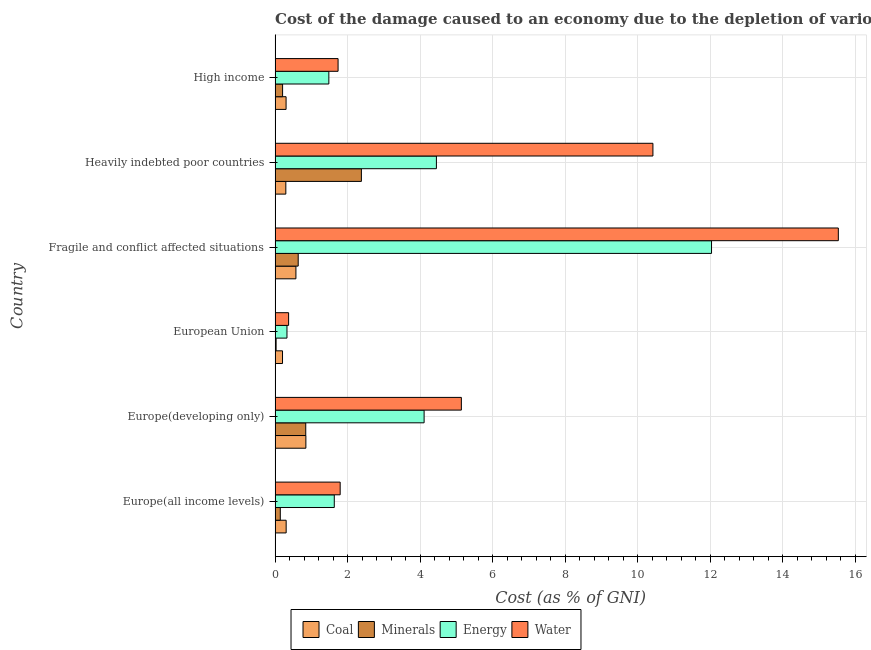How many different coloured bars are there?
Provide a succinct answer. 4. How many groups of bars are there?
Your response must be concise. 6. How many bars are there on the 6th tick from the top?
Keep it short and to the point. 4. How many bars are there on the 6th tick from the bottom?
Provide a succinct answer. 4. What is the label of the 6th group of bars from the top?
Offer a very short reply. Europe(all income levels). What is the cost of damage due to depletion of energy in Heavily indebted poor countries?
Your response must be concise. 4.45. Across all countries, what is the maximum cost of damage due to depletion of coal?
Your response must be concise. 0.85. Across all countries, what is the minimum cost of damage due to depletion of minerals?
Your answer should be very brief. 0.03. In which country was the cost of damage due to depletion of minerals maximum?
Your answer should be compact. Heavily indebted poor countries. What is the total cost of damage due to depletion of water in the graph?
Provide a short and direct response. 34.99. What is the difference between the cost of damage due to depletion of water in Europe(developing only) and that in Heavily indebted poor countries?
Provide a short and direct response. -5.28. What is the difference between the cost of damage due to depletion of water in Heavily indebted poor countries and the cost of damage due to depletion of energy in European Union?
Offer a terse response. 10.09. What is the average cost of damage due to depletion of coal per country?
Your response must be concise. 0.42. What is the difference between the cost of damage due to depletion of energy and cost of damage due to depletion of coal in High income?
Keep it short and to the point. 1.18. What is the ratio of the cost of damage due to depletion of energy in Europe(all income levels) to that in High income?
Offer a very short reply. 1.1. What is the difference between the highest and the second highest cost of damage due to depletion of minerals?
Offer a very short reply. 1.53. What is the difference between the highest and the lowest cost of damage due to depletion of energy?
Provide a succinct answer. 11.7. What does the 3rd bar from the top in Heavily indebted poor countries represents?
Offer a terse response. Minerals. What does the 1st bar from the bottom in High income represents?
Your response must be concise. Coal. Are all the bars in the graph horizontal?
Keep it short and to the point. Yes. Are the values on the major ticks of X-axis written in scientific E-notation?
Provide a succinct answer. No. Does the graph contain any zero values?
Provide a short and direct response. No. Does the graph contain grids?
Offer a terse response. Yes. Where does the legend appear in the graph?
Make the answer very short. Bottom center. How are the legend labels stacked?
Offer a very short reply. Horizontal. What is the title of the graph?
Give a very brief answer. Cost of the damage caused to an economy due to the depletion of various resources in 2010 . Does "Self-employed" appear as one of the legend labels in the graph?
Offer a very short reply. No. What is the label or title of the X-axis?
Your response must be concise. Cost (as % of GNI). What is the label or title of the Y-axis?
Ensure brevity in your answer.  Country. What is the Cost (as % of GNI) of Coal in Europe(all income levels)?
Make the answer very short. 0.31. What is the Cost (as % of GNI) of Minerals in Europe(all income levels)?
Your answer should be very brief. 0.14. What is the Cost (as % of GNI) of Energy in Europe(all income levels)?
Give a very brief answer. 1.63. What is the Cost (as % of GNI) in Water in Europe(all income levels)?
Give a very brief answer. 1.79. What is the Cost (as % of GNI) of Coal in Europe(developing only)?
Your answer should be compact. 0.85. What is the Cost (as % of GNI) in Minerals in Europe(developing only)?
Ensure brevity in your answer.  0.85. What is the Cost (as % of GNI) in Energy in Europe(developing only)?
Offer a very short reply. 4.11. What is the Cost (as % of GNI) of Water in Europe(developing only)?
Offer a very short reply. 5.14. What is the Cost (as % of GNI) of Coal in European Union?
Your answer should be very brief. 0.21. What is the Cost (as % of GNI) of Minerals in European Union?
Your response must be concise. 0.03. What is the Cost (as % of GNI) in Energy in European Union?
Offer a very short reply. 0.33. What is the Cost (as % of GNI) of Water in European Union?
Offer a terse response. 0.37. What is the Cost (as % of GNI) of Coal in Fragile and conflict affected situations?
Keep it short and to the point. 0.57. What is the Cost (as % of GNI) of Minerals in Fragile and conflict affected situations?
Offer a terse response. 0.64. What is the Cost (as % of GNI) of Energy in Fragile and conflict affected situations?
Provide a succinct answer. 12.03. What is the Cost (as % of GNI) in Water in Fragile and conflict affected situations?
Your answer should be compact. 15.53. What is the Cost (as % of GNI) in Coal in Heavily indebted poor countries?
Your response must be concise. 0.3. What is the Cost (as % of GNI) in Minerals in Heavily indebted poor countries?
Make the answer very short. 2.38. What is the Cost (as % of GNI) of Energy in Heavily indebted poor countries?
Provide a short and direct response. 4.45. What is the Cost (as % of GNI) of Water in Heavily indebted poor countries?
Your response must be concise. 10.42. What is the Cost (as % of GNI) in Coal in High income?
Offer a terse response. 0.3. What is the Cost (as % of GNI) in Minerals in High income?
Give a very brief answer. 0.21. What is the Cost (as % of GNI) in Energy in High income?
Ensure brevity in your answer.  1.48. What is the Cost (as % of GNI) in Water in High income?
Keep it short and to the point. 1.74. Across all countries, what is the maximum Cost (as % of GNI) of Coal?
Give a very brief answer. 0.85. Across all countries, what is the maximum Cost (as % of GNI) in Minerals?
Offer a terse response. 2.38. Across all countries, what is the maximum Cost (as % of GNI) in Energy?
Your answer should be very brief. 12.03. Across all countries, what is the maximum Cost (as % of GNI) in Water?
Keep it short and to the point. 15.53. Across all countries, what is the minimum Cost (as % of GNI) in Coal?
Offer a terse response. 0.21. Across all countries, what is the minimum Cost (as % of GNI) of Minerals?
Offer a very short reply. 0.03. Across all countries, what is the minimum Cost (as % of GNI) of Energy?
Your response must be concise. 0.33. Across all countries, what is the minimum Cost (as % of GNI) in Water?
Your answer should be very brief. 0.37. What is the total Cost (as % of GNI) of Coal in the graph?
Provide a succinct answer. 2.53. What is the total Cost (as % of GNI) in Minerals in the graph?
Offer a terse response. 4.24. What is the total Cost (as % of GNI) of Energy in the graph?
Ensure brevity in your answer.  24.03. What is the total Cost (as % of GNI) of Water in the graph?
Provide a short and direct response. 34.99. What is the difference between the Cost (as % of GNI) of Coal in Europe(all income levels) and that in Europe(developing only)?
Make the answer very short. -0.54. What is the difference between the Cost (as % of GNI) in Minerals in Europe(all income levels) and that in Europe(developing only)?
Your answer should be very brief. -0.7. What is the difference between the Cost (as % of GNI) in Energy in Europe(all income levels) and that in Europe(developing only)?
Give a very brief answer. -2.48. What is the difference between the Cost (as % of GNI) in Water in Europe(all income levels) and that in Europe(developing only)?
Offer a very short reply. -3.34. What is the difference between the Cost (as % of GNI) in Coal in Europe(all income levels) and that in European Union?
Give a very brief answer. 0.1. What is the difference between the Cost (as % of GNI) of Minerals in Europe(all income levels) and that in European Union?
Give a very brief answer. 0.12. What is the difference between the Cost (as % of GNI) in Energy in Europe(all income levels) and that in European Union?
Offer a terse response. 1.3. What is the difference between the Cost (as % of GNI) in Water in Europe(all income levels) and that in European Union?
Ensure brevity in your answer.  1.42. What is the difference between the Cost (as % of GNI) in Coal in Europe(all income levels) and that in Fragile and conflict affected situations?
Provide a short and direct response. -0.27. What is the difference between the Cost (as % of GNI) of Minerals in Europe(all income levels) and that in Fragile and conflict affected situations?
Ensure brevity in your answer.  -0.49. What is the difference between the Cost (as % of GNI) of Energy in Europe(all income levels) and that in Fragile and conflict affected situations?
Your answer should be very brief. -10.4. What is the difference between the Cost (as % of GNI) in Water in Europe(all income levels) and that in Fragile and conflict affected situations?
Provide a short and direct response. -13.73. What is the difference between the Cost (as % of GNI) of Coal in Europe(all income levels) and that in Heavily indebted poor countries?
Provide a short and direct response. 0.01. What is the difference between the Cost (as % of GNI) of Minerals in Europe(all income levels) and that in Heavily indebted poor countries?
Your answer should be very brief. -2.24. What is the difference between the Cost (as % of GNI) in Energy in Europe(all income levels) and that in Heavily indebted poor countries?
Your answer should be compact. -2.82. What is the difference between the Cost (as % of GNI) in Water in Europe(all income levels) and that in Heavily indebted poor countries?
Offer a very short reply. -8.62. What is the difference between the Cost (as % of GNI) of Coal in Europe(all income levels) and that in High income?
Keep it short and to the point. 0. What is the difference between the Cost (as % of GNI) in Minerals in Europe(all income levels) and that in High income?
Your answer should be very brief. -0.06. What is the difference between the Cost (as % of GNI) of Energy in Europe(all income levels) and that in High income?
Offer a terse response. 0.15. What is the difference between the Cost (as % of GNI) of Water in Europe(all income levels) and that in High income?
Make the answer very short. 0.06. What is the difference between the Cost (as % of GNI) of Coal in Europe(developing only) and that in European Union?
Your answer should be very brief. 0.64. What is the difference between the Cost (as % of GNI) of Minerals in Europe(developing only) and that in European Union?
Provide a succinct answer. 0.82. What is the difference between the Cost (as % of GNI) of Energy in Europe(developing only) and that in European Union?
Offer a very short reply. 3.78. What is the difference between the Cost (as % of GNI) of Water in Europe(developing only) and that in European Union?
Provide a succinct answer. 4.76. What is the difference between the Cost (as % of GNI) of Coal in Europe(developing only) and that in Fragile and conflict affected situations?
Your answer should be very brief. 0.27. What is the difference between the Cost (as % of GNI) of Minerals in Europe(developing only) and that in Fragile and conflict affected situations?
Your answer should be very brief. 0.21. What is the difference between the Cost (as % of GNI) of Energy in Europe(developing only) and that in Fragile and conflict affected situations?
Your answer should be very brief. -7.92. What is the difference between the Cost (as % of GNI) of Water in Europe(developing only) and that in Fragile and conflict affected situations?
Provide a succinct answer. -10.39. What is the difference between the Cost (as % of GNI) in Coal in Europe(developing only) and that in Heavily indebted poor countries?
Offer a very short reply. 0.55. What is the difference between the Cost (as % of GNI) of Minerals in Europe(developing only) and that in Heavily indebted poor countries?
Provide a succinct answer. -1.53. What is the difference between the Cost (as % of GNI) of Energy in Europe(developing only) and that in Heavily indebted poor countries?
Make the answer very short. -0.34. What is the difference between the Cost (as % of GNI) of Water in Europe(developing only) and that in Heavily indebted poor countries?
Provide a short and direct response. -5.28. What is the difference between the Cost (as % of GNI) of Coal in Europe(developing only) and that in High income?
Ensure brevity in your answer.  0.55. What is the difference between the Cost (as % of GNI) in Minerals in Europe(developing only) and that in High income?
Your answer should be very brief. 0.64. What is the difference between the Cost (as % of GNI) of Energy in Europe(developing only) and that in High income?
Give a very brief answer. 2.63. What is the difference between the Cost (as % of GNI) of Water in Europe(developing only) and that in High income?
Your answer should be compact. 3.4. What is the difference between the Cost (as % of GNI) of Coal in European Union and that in Fragile and conflict affected situations?
Keep it short and to the point. -0.37. What is the difference between the Cost (as % of GNI) in Minerals in European Union and that in Fragile and conflict affected situations?
Keep it short and to the point. -0.61. What is the difference between the Cost (as % of GNI) in Energy in European Union and that in Fragile and conflict affected situations?
Ensure brevity in your answer.  -11.7. What is the difference between the Cost (as % of GNI) in Water in European Union and that in Fragile and conflict affected situations?
Make the answer very short. -15.16. What is the difference between the Cost (as % of GNI) of Coal in European Union and that in Heavily indebted poor countries?
Provide a short and direct response. -0.09. What is the difference between the Cost (as % of GNI) of Minerals in European Union and that in Heavily indebted poor countries?
Your answer should be very brief. -2.35. What is the difference between the Cost (as % of GNI) of Energy in European Union and that in Heavily indebted poor countries?
Make the answer very short. -4.12. What is the difference between the Cost (as % of GNI) in Water in European Union and that in Heavily indebted poor countries?
Ensure brevity in your answer.  -10.04. What is the difference between the Cost (as % of GNI) in Coal in European Union and that in High income?
Offer a very short reply. -0.1. What is the difference between the Cost (as % of GNI) in Minerals in European Union and that in High income?
Keep it short and to the point. -0.18. What is the difference between the Cost (as % of GNI) of Energy in European Union and that in High income?
Offer a very short reply. -1.15. What is the difference between the Cost (as % of GNI) of Water in European Union and that in High income?
Your response must be concise. -1.36. What is the difference between the Cost (as % of GNI) of Coal in Fragile and conflict affected situations and that in Heavily indebted poor countries?
Your answer should be very brief. 0.28. What is the difference between the Cost (as % of GNI) of Minerals in Fragile and conflict affected situations and that in Heavily indebted poor countries?
Offer a very short reply. -1.74. What is the difference between the Cost (as % of GNI) of Energy in Fragile and conflict affected situations and that in Heavily indebted poor countries?
Your answer should be very brief. 7.58. What is the difference between the Cost (as % of GNI) of Water in Fragile and conflict affected situations and that in Heavily indebted poor countries?
Your answer should be very brief. 5.11. What is the difference between the Cost (as % of GNI) of Coal in Fragile and conflict affected situations and that in High income?
Your answer should be compact. 0.27. What is the difference between the Cost (as % of GNI) in Minerals in Fragile and conflict affected situations and that in High income?
Make the answer very short. 0.43. What is the difference between the Cost (as % of GNI) in Energy in Fragile and conflict affected situations and that in High income?
Offer a very short reply. 10.55. What is the difference between the Cost (as % of GNI) of Water in Fragile and conflict affected situations and that in High income?
Keep it short and to the point. 13.79. What is the difference between the Cost (as % of GNI) in Coal in Heavily indebted poor countries and that in High income?
Your response must be concise. -0.01. What is the difference between the Cost (as % of GNI) in Minerals in Heavily indebted poor countries and that in High income?
Give a very brief answer. 2.17. What is the difference between the Cost (as % of GNI) in Energy in Heavily indebted poor countries and that in High income?
Keep it short and to the point. 2.97. What is the difference between the Cost (as % of GNI) in Water in Heavily indebted poor countries and that in High income?
Ensure brevity in your answer.  8.68. What is the difference between the Cost (as % of GNI) in Coal in Europe(all income levels) and the Cost (as % of GNI) in Minerals in Europe(developing only)?
Ensure brevity in your answer.  -0.54. What is the difference between the Cost (as % of GNI) of Coal in Europe(all income levels) and the Cost (as % of GNI) of Energy in Europe(developing only)?
Make the answer very short. -3.8. What is the difference between the Cost (as % of GNI) of Coal in Europe(all income levels) and the Cost (as % of GNI) of Water in Europe(developing only)?
Keep it short and to the point. -4.83. What is the difference between the Cost (as % of GNI) of Minerals in Europe(all income levels) and the Cost (as % of GNI) of Energy in Europe(developing only)?
Ensure brevity in your answer.  -3.96. What is the difference between the Cost (as % of GNI) of Minerals in Europe(all income levels) and the Cost (as % of GNI) of Water in Europe(developing only)?
Ensure brevity in your answer.  -4.99. What is the difference between the Cost (as % of GNI) of Energy in Europe(all income levels) and the Cost (as % of GNI) of Water in Europe(developing only)?
Keep it short and to the point. -3.5. What is the difference between the Cost (as % of GNI) in Coal in Europe(all income levels) and the Cost (as % of GNI) in Minerals in European Union?
Your response must be concise. 0.28. What is the difference between the Cost (as % of GNI) in Coal in Europe(all income levels) and the Cost (as % of GNI) in Energy in European Union?
Your answer should be very brief. -0.02. What is the difference between the Cost (as % of GNI) in Coal in Europe(all income levels) and the Cost (as % of GNI) in Water in European Union?
Keep it short and to the point. -0.07. What is the difference between the Cost (as % of GNI) in Minerals in Europe(all income levels) and the Cost (as % of GNI) in Energy in European Union?
Give a very brief answer. -0.18. What is the difference between the Cost (as % of GNI) of Minerals in Europe(all income levels) and the Cost (as % of GNI) of Water in European Union?
Offer a terse response. -0.23. What is the difference between the Cost (as % of GNI) of Energy in Europe(all income levels) and the Cost (as % of GNI) of Water in European Union?
Your answer should be compact. 1.26. What is the difference between the Cost (as % of GNI) in Coal in Europe(all income levels) and the Cost (as % of GNI) in Minerals in Fragile and conflict affected situations?
Your answer should be compact. -0.33. What is the difference between the Cost (as % of GNI) in Coal in Europe(all income levels) and the Cost (as % of GNI) in Energy in Fragile and conflict affected situations?
Your answer should be very brief. -11.73. What is the difference between the Cost (as % of GNI) of Coal in Europe(all income levels) and the Cost (as % of GNI) of Water in Fragile and conflict affected situations?
Your answer should be compact. -15.22. What is the difference between the Cost (as % of GNI) of Minerals in Europe(all income levels) and the Cost (as % of GNI) of Energy in Fragile and conflict affected situations?
Offer a terse response. -11.89. What is the difference between the Cost (as % of GNI) of Minerals in Europe(all income levels) and the Cost (as % of GNI) of Water in Fragile and conflict affected situations?
Keep it short and to the point. -15.38. What is the difference between the Cost (as % of GNI) of Energy in Europe(all income levels) and the Cost (as % of GNI) of Water in Fragile and conflict affected situations?
Offer a very short reply. -13.9. What is the difference between the Cost (as % of GNI) of Coal in Europe(all income levels) and the Cost (as % of GNI) of Minerals in Heavily indebted poor countries?
Your answer should be very brief. -2.07. What is the difference between the Cost (as % of GNI) of Coal in Europe(all income levels) and the Cost (as % of GNI) of Energy in Heavily indebted poor countries?
Give a very brief answer. -4.14. What is the difference between the Cost (as % of GNI) of Coal in Europe(all income levels) and the Cost (as % of GNI) of Water in Heavily indebted poor countries?
Give a very brief answer. -10.11. What is the difference between the Cost (as % of GNI) of Minerals in Europe(all income levels) and the Cost (as % of GNI) of Energy in Heavily indebted poor countries?
Provide a short and direct response. -4.3. What is the difference between the Cost (as % of GNI) in Minerals in Europe(all income levels) and the Cost (as % of GNI) in Water in Heavily indebted poor countries?
Give a very brief answer. -10.27. What is the difference between the Cost (as % of GNI) in Energy in Europe(all income levels) and the Cost (as % of GNI) in Water in Heavily indebted poor countries?
Provide a short and direct response. -8.78. What is the difference between the Cost (as % of GNI) of Coal in Europe(all income levels) and the Cost (as % of GNI) of Minerals in High income?
Ensure brevity in your answer.  0.1. What is the difference between the Cost (as % of GNI) of Coal in Europe(all income levels) and the Cost (as % of GNI) of Energy in High income?
Offer a very short reply. -1.18. What is the difference between the Cost (as % of GNI) of Coal in Europe(all income levels) and the Cost (as % of GNI) of Water in High income?
Keep it short and to the point. -1.43. What is the difference between the Cost (as % of GNI) in Minerals in Europe(all income levels) and the Cost (as % of GNI) in Energy in High income?
Ensure brevity in your answer.  -1.34. What is the difference between the Cost (as % of GNI) of Minerals in Europe(all income levels) and the Cost (as % of GNI) of Water in High income?
Ensure brevity in your answer.  -1.59. What is the difference between the Cost (as % of GNI) in Energy in Europe(all income levels) and the Cost (as % of GNI) in Water in High income?
Make the answer very short. -0.1. What is the difference between the Cost (as % of GNI) of Coal in Europe(developing only) and the Cost (as % of GNI) of Minerals in European Union?
Provide a succinct answer. 0.82. What is the difference between the Cost (as % of GNI) in Coal in Europe(developing only) and the Cost (as % of GNI) in Energy in European Union?
Provide a short and direct response. 0.52. What is the difference between the Cost (as % of GNI) of Coal in Europe(developing only) and the Cost (as % of GNI) of Water in European Union?
Your response must be concise. 0.48. What is the difference between the Cost (as % of GNI) of Minerals in Europe(developing only) and the Cost (as % of GNI) of Energy in European Union?
Provide a succinct answer. 0.52. What is the difference between the Cost (as % of GNI) in Minerals in Europe(developing only) and the Cost (as % of GNI) in Water in European Union?
Your answer should be compact. 0.47. What is the difference between the Cost (as % of GNI) of Energy in Europe(developing only) and the Cost (as % of GNI) of Water in European Union?
Your response must be concise. 3.74. What is the difference between the Cost (as % of GNI) in Coal in Europe(developing only) and the Cost (as % of GNI) in Minerals in Fragile and conflict affected situations?
Provide a short and direct response. 0.21. What is the difference between the Cost (as % of GNI) of Coal in Europe(developing only) and the Cost (as % of GNI) of Energy in Fragile and conflict affected situations?
Offer a very short reply. -11.18. What is the difference between the Cost (as % of GNI) of Coal in Europe(developing only) and the Cost (as % of GNI) of Water in Fragile and conflict affected situations?
Keep it short and to the point. -14.68. What is the difference between the Cost (as % of GNI) in Minerals in Europe(developing only) and the Cost (as % of GNI) in Energy in Fragile and conflict affected situations?
Give a very brief answer. -11.19. What is the difference between the Cost (as % of GNI) in Minerals in Europe(developing only) and the Cost (as % of GNI) in Water in Fragile and conflict affected situations?
Your response must be concise. -14.68. What is the difference between the Cost (as % of GNI) in Energy in Europe(developing only) and the Cost (as % of GNI) in Water in Fragile and conflict affected situations?
Your response must be concise. -11.42. What is the difference between the Cost (as % of GNI) of Coal in Europe(developing only) and the Cost (as % of GNI) of Minerals in Heavily indebted poor countries?
Your answer should be compact. -1.53. What is the difference between the Cost (as % of GNI) of Coal in Europe(developing only) and the Cost (as % of GNI) of Energy in Heavily indebted poor countries?
Your answer should be compact. -3.6. What is the difference between the Cost (as % of GNI) of Coal in Europe(developing only) and the Cost (as % of GNI) of Water in Heavily indebted poor countries?
Your answer should be very brief. -9.57. What is the difference between the Cost (as % of GNI) of Minerals in Europe(developing only) and the Cost (as % of GNI) of Energy in Heavily indebted poor countries?
Provide a short and direct response. -3.6. What is the difference between the Cost (as % of GNI) of Minerals in Europe(developing only) and the Cost (as % of GNI) of Water in Heavily indebted poor countries?
Offer a terse response. -9.57. What is the difference between the Cost (as % of GNI) in Energy in Europe(developing only) and the Cost (as % of GNI) in Water in Heavily indebted poor countries?
Provide a short and direct response. -6.31. What is the difference between the Cost (as % of GNI) in Coal in Europe(developing only) and the Cost (as % of GNI) in Minerals in High income?
Provide a short and direct response. 0.64. What is the difference between the Cost (as % of GNI) of Coal in Europe(developing only) and the Cost (as % of GNI) of Energy in High income?
Offer a very short reply. -0.63. What is the difference between the Cost (as % of GNI) of Coal in Europe(developing only) and the Cost (as % of GNI) of Water in High income?
Your answer should be very brief. -0.89. What is the difference between the Cost (as % of GNI) of Minerals in Europe(developing only) and the Cost (as % of GNI) of Energy in High income?
Ensure brevity in your answer.  -0.64. What is the difference between the Cost (as % of GNI) of Minerals in Europe(developing only) and the Cost (as % of GNI) of Water in High income?
Keep it short and to the point. -0.89. What is the difference between the Cost (as % of GNI) in Energy in Europe(developing only) and the Cost (as % of GNI) in Water in High income?
Your response must be concise. 2.37. What is the difference between the Cost (as % of GNI) of Coal in European Union and the Cost (as % of GNI) of Minerals in Fragile and conflict affected situations?
Give a very brief answer. -0.43. What is the difference between the Cost (as % of GNI) in Coal in European Union and the Cost (as % of GNI) in Energy in Fragile and conflict affected situations?
Give a very brief answer. -11.83. What is the difference between the Cost (as % of GNI) in Coal in European Union and the Cost (as % of GNI) in Water in Fragile and conflict affected situations?
Provide a succinct answer. -15.32. What is the difference between the Cost (as % of GNI) in Minerals in European Union and the Cost (as % of GNI) in Energy in Fragile and conflict affected situations?
Offer a very short reply. -12. What is the difference between the Cost (as % of GNI) in Minerals in European Union and the Cost (as % of GNI) in Water in Fragile and conflict affected situations?
Offer a very short reply. -15.5. What is the difference between the Cost (as % of GNI) in Energy in European Union and the Cost (as % of GNI) in Water in Fragile and conflict affected situations?
Offer a terse response. -15.2. What is the difference between the Cost (as % of GNI) in Coal in European Union and the Cost (as % of GNI) in Minerals in Heavily indebted poor countries?
Provide a succinct answer. -2.17. What is the difference between the Cost (as % of GNI) of Coal in European Union and the Cost (as % of GNI) of Energy in Heavily indebted poor countries?
Offer a very short reply. -4.24. What is the difference between the Cost (as % of GNI) in Coal in European Union and the Cost (as % of GNI) in Water in Heavily indebted poor countries?
Provide a short and direct response. -10.21. What is the difference between the Cost (as % of GNI) in Minerals in European Union and the Cost (as % of GNI) in Energy in Heavily indebted poor countries?
Make the answer very short. -4.42. What is the difference between the Cost (as % of GNI) of Minerals in European Union and the Cost (as % of GNI) of Water in Heavily indebted poor countries?
Your answer should be very brief. -10.39. What is the difference between the Cost (as % of GNI) in Energy in European Union and the Cost (as % of GNI) in Water in Heavily indebted poor countries?
Ensure brevity in your answer.  -10.09. What is the difference between the Cost (as % of GNI) in Coal in European Union and the Cost (as % of GNI) in Minerals in High income?
Provide a succinct answer. -0. What is the difference between the Cost (as % of GNI) of Coal in European Union and the Cost (as % of GNI) of Energy in High income?
Make the answer very short. -1.28. What is the difference between the Cost (as % of GNI) of Coal in European Union and the Cost (as % of GNI) of Water in High income?
Your response must be concise. -1.53. What is the difference between the Cost (as % of GNI) in Minerals in European Union and the Cost (as % of GNI) in Energy in High income?
Offer a very short reply. -1.45. What is the difference between the Cost (as % of GNI) in Minerals in European Union and the Cost (as % of GNI) in Water in High income?
Keep it short and to the point. -1.71. What is the difference between the Cost (as % of GNI) of Energy in European Union and the Cost (as % of GNI) of Water in High income?
Your response must be concise. -1.41. What is the difference between the Cost (as % of GNI) of Coal in Fragile and conflict affected situations and the Cost (as % of GNI) of Minerals in Heavily indebted poor countries?
Ensure brevity in your answer.  -1.8. What is the difference between the Cost (as % of GNI) of Coal in Fragile and conflict affected situations and the Cost (as % of GNI) of Energy in Heavily indebted poor countries?
Offer a very short reply. -3.87. What is the difference between the Cost (as % of GNI) in Coal in Fragile and conflict affected situations and the Cost (as % of GNI) in Water in Heavily indebted poor countries?
Make the answer very short. -9.84. What is the difference between the Cost (as % of GNI) of Minerals in Fragile and conflict affected situations and the Cost (as % of GNI) of Energy in Heavily indebted poor countries?
Your response must be concise. -3.81. What is the difference between the Cost (as % of GNI) of Minerals in Fragile and conflict affected situations and the Cost (as % of GNI) of Water in Heavily indebted poor countries?
Provide a succinct answer. -9.78. What is the difference between the Cost (as % of GNI) of Energy in Fragile and conflict affected situations and the Cost (as % of GNI) of Water in Heavily indebted poor countries?
Provide a short and direct response. 1.62. What is the difference between the Cost (as % of GNI) in Coal in Fragile and conflict affected situations and the Cost (as % of GNI) in Minerals in High income?
Give a very brief answer. 0.37. What is the difference between the Cost (as % of GNI) in Coal in Fragile and conflict affected situations and the Cost (as % of GNI) in Energy in High income?
Provide a short and direct response. -0.91. What is the difference between the Cost (as % of GNI) in Coal in Fragile and conflict affected situations and the Cost (as % of GNI) in Water in High income?
Provide a short and direct response. -1.16. What is the difference between the Cost (as % of GNI) of Minerals in Fragile and conflict affected situations and the Cost (as % of GNI) of Energy in High income?
Your answer should be compact. -0.84. What is the difference between the Cost (as % of GNI) of Minerals in Fragile and conflict affected situations and the Cost (as % of GNI) of Water in High income?
Keep it short and to the point. -1.1. What is the difference between the Cost (as % of GNI) of Energy in Fragile and conflict affected situations and the Cost (as % of GNI) of Water in High income?
Your response must be concise. 10.3. What is the difference between the Cost (as % of GNI) in Coal in Heavily indebted poor countries and the Cost (as % of GNI) in Minerals in High income?
Your response must be concise. 0.09. What is the difference between the Cost (as % of GNI) in Coal in Heavily indebted poor countries and the Cost (as % of GNI) in Energy in High income?
Your response must be concise. -1.19. What is the difference between the Cost (as % of GNI) of Coal in Heavily indebted poor countries and the Cost (as % of GNI) of Water in High income?
Your response must be concise. -1.44. What is the difference between the Cost (as % of GNI) of Minerals in Heavily indebted poor countries and the Cost (as % of GNI) of Energy in High income?
Your response must be concise. 0.9. What is the difference between the Cost (as % of GNI) in Minerals in Heavily indebted poor countries and the Cost (as % of GNI) in Water in High income?
Your answer should be compact. 0.64. What is the difference between the Cost (as % of GNI) in Energy in Heavily indebted poor countries and the Cost (as % of GNI) in Water in High income?
Provide a succinct answer. 2.71. What is the average Cost (as % of GNI) in Coal per country?
Keep it short and to the point. 0.42. What is the average Cost (as % of GNI) in Minerals per country?
Your answer should be very brief. 0.71. What is the average Cost (as % of GNI) of Energy per country?
Your answer should be compact. 4.01. What is the average Cost (as % of GNI) of Water per country?
Offer a very short reply. 5.83. What is the difference between the Cost (as % of GNI) of Coal and Cost (as % of GNI) of Minerals in Europe(all income levels)?
Provide a succinct answer. 0.16. What is the difference between the Cost (as % of GNI) in Coal and Cost (as % of GNI) in Energy in Europe(all income levels)?
Ensure brevity in your answer.  -1.33. What is the difference between the Cost (as % of GNI) of Coal and Cost (as % of GNI) of Water in Europe(all income levels)?
Your answer should be very brief. -1.49. What is the difference between the Cost (as % of GNI) of Minerals and Cost (as % of GNI) of Energy in Europe(all income levels)?
Ensure brevity in your answer.  -1.49. What is the difference between the Cost (as % of GNI) in Minerals and Cost (as % of GNI) in Water in Europe(all income levels)?
Offer a terse response. -1.65. What is the difference between the Cost (as % of GNI) in Energy and Cost (as % of GNI) in Water in Europe(all income levels)?
Offer a terse response. -0.16. What is the difference between the Cost (as % of GNI) of Coal and Cost (as % of GNI) of Minerals in Europe(developing only)?
Keep it short and to the point. 0. What is the difference between the Cost (as % of GNI) of Coal and Cost (as % of GNI) of Energy in Europe(developing only)?
Provide a succinct answer. -3.26. What is the difference between the Cost (as % of GNI) of Coal and Cost (as % of GNI) of Water in Europe(developing only)?
Give a very brief answer. -4.29. What is the difference between the Cost (as % of GNI) of Minerals and Cost (as % of GNI) of Energy in Europe(developing only)?
Provide a succinct answer. -3.26. What is the difference between the Cost (as % of GNI) in Minerals and Cost (as % of GNI) in Water in Europe(developing only)?
Provide a short and direct response. -4.29. What is the difference between the Cost (as % of GNI) of Energy and Cost (as % of GNI) of Water in Europe(developing only)?
Provide a short and direct response. -1.03. What is the difference between the Cost (as % of GNI) in Coal and Cost (as % of GNI) in Minerals in European Union?
Offer a terse response. 0.18. What is the difference between the Cost (as % of GNI) in Coal and Cost (as % of GNI) in Energy in European Union?
Your answer should be compact. -0.12. What is the difference between the Cost (as % of GNI) in Coal and Cost (as % of GNI) in Water in European Union?
Offer a very short reply. -0.17. What is the difference between the Cost (as % of GNI) in Minerals and Cost (as % of GNI) in Energy in European Union?
Make the answer very short. -0.3. What is the difference between the Cost (as % of GNI) of Minerals and Cost (as % of GNI) of Water in European Union?
Your answer should be compact. -0.34. What is the difference between the Cost (as % of GNI) of Energy and Cost (as % of GNI) of Water in European Union?
Make the answer very short. -0.05. What is the difference between the Cost (as % of GNI) of Coal and Cost (as % of GNI) of Minerals in Fragile and conflict affected situations?
Give a very brief answer. -0.06. What is the difference between the Cost (as % of GNI) of Coal and Cost (as % of GNI) of Energy in Fragile and conflict affected situations?
Keep it short and to the point. -11.46. What is the difference between the Cost (as % of GNI) of Coal and Cost (as % of GNI) of Water in Fragile and conflict affected situations?
Offer a terse response. -14.95. What is the difference between the Cost (as % of GNI) of Minerals and Cost (as % of GNI) of Energy in Fragile and conflict affected situations?
Provide a succinct answer. -11.39. What is the difference between the Cost (as % of GNI) of Minerals and Cost (as % of GNI) of Water in Fragile and conflict affected situations?
Your response must be concise. -14.89. What is the difference between the Cost (as % of GNI) of Energy and Cost (as % of GNI) of Water in Fragile and conflict affected situations?
Provide a succinct answer. -3.5. What is the difference between the Cost (as % of GNI) of Coal and Cost (as % of GNI) of Minerals in Heavily indebted poor countries?
Provide a short and direct response. -2.08. What is the difference between the Cost (as % of GNI) of Coal and Cost (as % of GNI) of Energy in Heavily indebted poor countries?
Your response must be concise. -4.15. What is the difference between the Cost (as % of GNI) in Coal and Cost (as % of GNI) in Water in Heavily indebted poor countries?
Offer a terse response. -10.12. What is the difference between the Cost (as % of GNI) of Minerals and Cost (as % of GNI) of Energy in Heavily indebted poor countries?
Offer a very short reply. -2.07. What is the difference between the Cost (as % of GNI) in Minerals and Cost (as % of GNI) in Water in Heavily indebted poor countries?
Provide a short and direct response. -8.04. What is the difference between the Cost (as % of GNI) in Energy and Cost (as % of GNI) in Water in Heavily indebted poor countries?
Offer a terse response. -5.97. What is the difference between the Cost (as % of GNI) of Coal and Cost (as % of GNI) of Minerals in High income?
Your answer should be compact. 0.1. What is the difference between the Cost (as % of GNI) of Coal and Cost (as % of GNI) of Energy in High income?
Provide a short and direct response. -1.18. What is the difference between the Cost (as % of GNI) in Coal and Cost (as % of GNI) in Water in High income?
Give a very brief answer. -1.43. What is the difference between the Cost (as % of GNI) in Minerals and Cost (as % of GNI) in Energy in High income?
Your answer should be compact. -1.28. What is the difference between the Cost (as % of GNI) of Minerals and Cost (as % of GNI) of Water in High income?
Your response must be concise. -1.53. What is the difference between the Cost (as % of GNI) of Energy and Cost (as % of GNI) of Water in High income?
Your response must be concise. -0.25. What is the ratio of the Cost (as % of GNI) of Coal in Europe(all income levels) to that in Europe(developing only)?
Offer a very short reply. 0.36. What is the ratio of the Cost (as % of GNI) in Minerals in Europe(all income levels) to that in Europe(developing only)?
Provide a succinct answer. 0.17. What is the ratio of the Cost (as % of GNI) in Energy in Europe(all income levels) to that in Europe(developing only)?
Your response must be concise. 0.4. What is the ratio of the Cost (as % of GNI) of Water in Europe(all income levels) to that in Europe(developing only)?
Your response must be concise. 0.35. What is the ratio of the Cost (as % of GNI) of Coal in Europe(all income levels) to that in European Union?
Make the answer very short. 1.49. What is the ratio of the Cost (as % of GNI) in Minerals in Europe(all income levels) to that in European Union?
Ensure brevity in your answer.  5.08. What is the ratio of the Cost (as % of GNI) of Energy in Europe(all income levels) to that in European Union?
Keep it short and to the point. 4.98. What is the ratio of the Cost (as % of GNI) of Water in Europe(all income levels) to that in European Union?
Offer a terse response. 4.81. What is the ratio of the Cost (as % of GNI) in Coal in Europe(all income levels) to that in Fragile and conflict affected situations?
Provide a succinct answer. 0.53. What is the ratio of the Cost (as % of GNI) of Minerals in Europe(all income levels) to that in Fragile and conflict affected situations?
Offer a terse response. 0.23. What is the ratio of the Cost (as % of GNI) of Energy in Europe(all income levels) to that in Fragile and conflict affected situations?
Offer a terse response. 0.14. What is the ratio of the Cost (as % of GNI) in Water in Europe(all income levels) to that in Fragile and conflict affected situations?
Provide a succinct answer. 0.12. What is the ratio of the Cost (as % of GNI) of Coal in Europe(all income levels) to that in Heavily indebted poor countries?
Make the answer very short. 1.03. What is the ratio of the Cost (as % of GNI) in Minerals in Europe(all income levels) to that in Heavily indebted poor countries?
Offer a terse response. 0.06. What is the ratio of the Cost (as % of GNI) in Energy in Europe(all income levels) to that in Heavily indebted poor countries?
Your answer should be very brief. 0.37. What is the ratio of the Cost (as % of GNI) in Water in Europe(all income levels) to that in Heavily indebted poor countries?
Keep it short and to the point. 0.17. What is the ratio of the Cost (as % of GNI) of Coal in Europe(all income levels) to that in High income?
Provide a short and direct response. 1.01. What is the ratio of the Cost (as % of GNI) in Minerals in Europe(all income levels) to that in High income?
Make the answer very short. 0.7. What is the ratio of the Cost (as % of GNI) of Energy in Europe(all income levels) to that in High income?
Your answer should be very brief. 1.1. What is the ratio of the Cost (as % of GNI) in Coal in Europe(developing only) to that in European Union?
Your answer should be compact. 4.14. What is the ratio of the Cost (as % of GNI) of Minerals in Europe(developing only) to that in European Union?
Offer a terse response. 29.8. What is the ratio of the Cost (as % of GNI) in Energy in Europe(developing only) to that in European Union?
Ensure brevity in your answer.  12.54. What is the ratio of the Cost (as % of GNI) in Water in Europe(developing only) to that in European Union?
Keep it short and to the point. 13.77. What is the ratio of the Cost (as % of GNI) of Coal in Europe(developing only) to that in Fragile and conflict affected situations?
Offer a terse response. 1.48. What is the ratio of the Cost (as % of GNI) of Minerals in Europe(developing only) to that in Fragile and conflict affected situations?
Your answer should be very brief. 1.33. What is the ratio of the Cost (as % of GNI) of Energy in Europe(developing only) to that in Fragile and conflict affected situations?
Your answer should be compact. 0.34. What is the ratio of the Cost (as % of GNI) in Water in Europe(developing only) to that in Fragile and conflict affected situations?
Offer a very short reply. 0.33. What is the ratio of the Cost (as % of GNI) in Coal in Europe(developing only) to that in Heavily indebted poor countries?
Keep it short and to the point. 2.86. What is the ratio of the Cost (as % of GNI) of Minerals in Europe(developing only) to that in Heavily indebted poor countries?
Your answer should be very brief. 0.36. What is the ratio of the Cost (as % of GNI) in Energy in Europe(developing only) to that in Heavily indebted poor countries?
Offer a very short reply. 0.92. What is the ratio of the Cost (as % of GNI) of Water in Europe(developing only) to that in Heavily indebted poor countries?
Offer a terse response. 0.49. What is the ratio of the Cost (as % of GNI) of Coal in Europe(developing only) to that in High income?
Provide a short and direct response. 2.8. What is the ratio of the Cost (as % of GNI) of Minerals in Europe(developing only) to that in High income?
Your answer should be compact. 4.08. What is the ratio of the Cost (as % of GNI) in Energy in Europe(developing only) to that in High income?
Make the answer very short. 2.77. What is the ratio of the Cost (as % of GNI) in Water in Europe(developing only) to that in High income?
Offer a very short reply. 2.96. What is the ratio of the Cost (as % of GNI) in Coal in European Union to that in Fragile and conflict affected situations?
Provide a short and direct response. 0.36. What is the ratio of the Cost (as % of GNI) of Minerals in European Union to that in Fragile and conflict affected situations?
Provide a succinct answer. 0.04. What is the ratio of the Cost (as % of GNI) of Energy in European Union to that in Fragile and conflict affected situations?
Your response must be concise. 0.03. What is the ratio of the Cost (as % of GNI) in Water in European Union to that in Fragile and conflict affected situations?
Provide a short and direct response. 0.02. What is the ratio of the Cost (as % of GNI) in Coal in European Union to that in Heavily indebted poor countries?
Keep it short and to the point. 0.69. What is the ratio of the Cost (as % of GNI) of Minerals in European Union to that in Heavily indebted poor countries?
Offer a very short reply. 0.01. What is the ratio of the Cost (as % of GNI) in Energy in European Union to that in Heavily indebted poor countries?
Offer a terse response. 0.07. What is the ratio of the Cost (as % of GNI) of Water in European Union to that in Heavily indebted poor countries?
Give a very brief answer. 0.04. What is the ratio of the Cost (as % of GNI) in Coal in European Union to that in High income?
Offer a terse response. 0.68. What is the ratio of the Cost (as % of GNI) in Minerals in European Union to that in High income?
Your answer should be compact. 0.14. What is the ratio of the Cost (as % of GNI) in Energy in European Union to that in High income?
Your answer should be very brief. 0.22. What is the ratio of the Cost (as % of GNI) in Water in European Union to that in High income?
Your answer should be compact. 0.21. What is the ratio of the Cost (as % of GNI) in Coal in Fragile and conflict affected situations to that in Heavily indebted poor countries?
Offer a terse response. 1.94. What is the ratio of the Cost (as % of GNI) of Minerals in Fragile and conflict affected situations to that in Heavily indebted poor countries?
Offer a terse response. 0.27. What is the ratio of the Cost (as % of GNI) in Energy in Fragile and conflict affected situations to that in Heavily indebted poor countries?
Ensure brevity in your answer.  2.71. What is the ratio of the Cost (as % of GNI) of Water in Fragile and conflict affected situations to that in Heavily indebted poor countries?
Ensure brevity in your answer.  1.49. What is the ratio of the Cost (as % of GNI) in Coal in Fragile and conflict affected situations to that in High income?
Provide a succinct answer. 1.9. What is the ratio of the Cost (as % of GNI) of Minerals in Fragile and conflict affected situations to that in High income?
Your response must be concise. 3.08. What is the ratio of the Cost (as % of GNI) in Energy in Fragile and conflict affected situations to that in High income?
Your answer should be very brief. 8.12. What is the ratio of the Cost (as % of GNI) in Water in Fragile and conflict affected situations to that in High income?
Your response must be concise. 8.94. What is the ratio of the Cost (as % of GNI) in Coal in Heavily indebted poor countries to that in High income?
Your response must be concise. 0.98. What is the ratio of the Cost (as % of GNI) of Minerals in Heavily indebted poor countries to that in High income?
Ensure brevity in your answer.  11.49. What is the ratio of the Cost (as % of GNI) in Energy in Heavily indebted poor countries to that in High income?
Your answer should be compact. 3. What is the ratio of the Cost (as % of GNI) of Water in Heavily indebted poor countries to that in High income?
Provide a succinct answer. 6. What is the difference between the highest and the second highest Cost (as % of GNI) in Coal?
Give a very brief answer. 0.27. What is the difference between the highest and the second highest Cost (as % of GNI) of Minerals?
Ensure brevity in your answer.  1.53. What is the difference between the highest and the second highest Cost (as % of GNI) in Energy?
Your response must be concise. 7.58. What is the difference between the highest and the second highest Cost (as % of GNI) in Water?
Provide a short and direct response. 5.11. What is the difference between the highest and the lowest Cost (as % of GNI) in Coal?
Provide a short and direct response. 0.64. What is the difference between the highest and the lowest Cost (as % of GNI) in Minerals?
Give a very brief answer. 2.35. What is the difference between the highest and the lowest Cost (as % of GNI) in Energy?
Your response must be concise. 11.7. What is the difference between the highest and the lowest Cost (as % of GNI) of Water?
Your answer should be very brief. 15.16. 